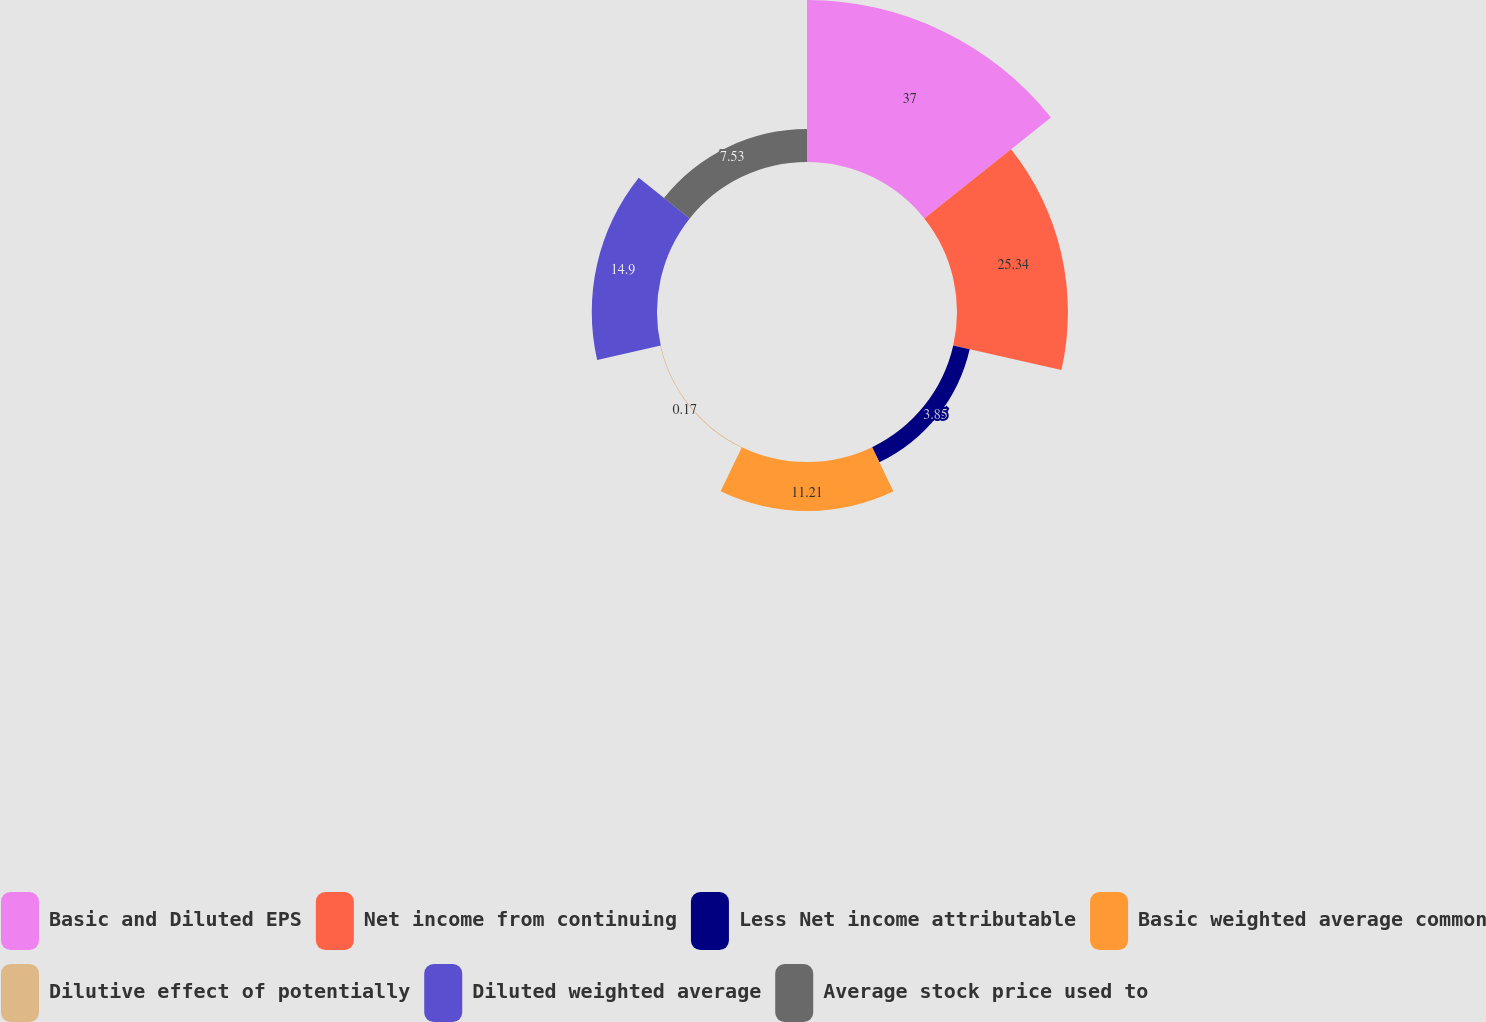Convert chart to OTSL. <chart><loc_0><loc_0><loc_500><loc_500><pie_chart><fcel>Basic and Diluted EPS<fcel>Net income from continuing<fcel>Less Net income attributable<fcel>Basic weighted average common<fcel>Dilutive effect of potentially<fcel>Diluted weighted average<fcel>Average stock price used to<nl><fcel>37.0%<fcel>25.34%<fcel>3.85%<fcel>11.21%<fcel>0.17%<fcel>14.9%<fcel>7.53%<nl></chart> 